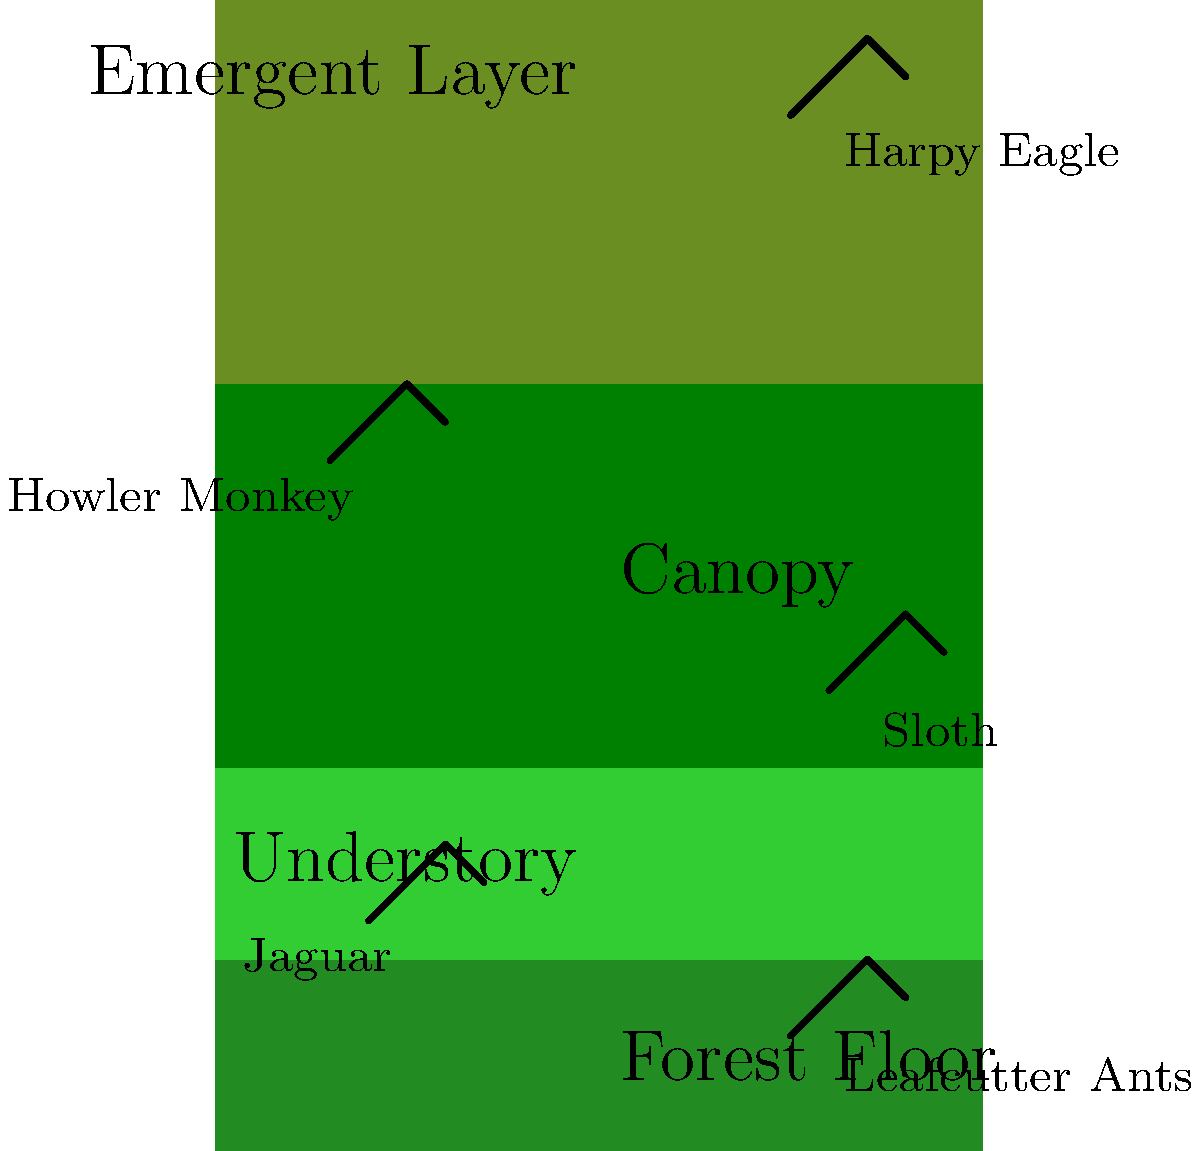As a nature photographer documenting the Amazon basin, you encounter various species at different levels of the rainforest. Based on the vertical diagram of the rainforest layers, which animal would you most likely find in the canopy layer, and what unique adaptation does this animal possess that makes it well-suited for life in this particular layer? To answer this question, let's analyze the diagram and consider the animals shown in each layer:

1. Emergent Layer: Harpy Eagle
2. Canopy: Howler Monkey
3. Understory: Sloth
4. Forest Floor: Jaguar and Leafcutter Ants

The question asks about an animal in the canopy layer, which is the Howler Monkey according to the diagram.

Howler Monkeys are well-adapted to life in the canopy for several reasons:

1. Prehensile tails: Howler Monkeys have long, strong tails that can grasp branches, providing extra support and balance while moving through the treetops.

2. Strong limbs: Their arms and legs are adapted for brachiation (swinging from branch to branch), allowing efficient movement through the canopy.

3. Specialized diet: Howler Monkeys primarily feed on leaves, fruits, and flowers found in abundance in the canopy layer.

4. Loud vocalizations: Their famous howls can travel long distances through the dense canopy, helping them communicate with other troops and establish territory.

5. Color vision: Unlike many mammals, Howler Monkeys have trichromatic vision, which helps them distinguish ripe fruits and young leaves in the varied colors of the canopy.

The most unique and notable adaptation of Howler Monkeys is their exceptionally loud vocalization, which is made possible by their enlarged hyoid bone. This adaptation allows them to communicate effectively in the dense canopy environment.
Answer: Howler Monkey; enlarged hyoid bone for loud vocalizations 